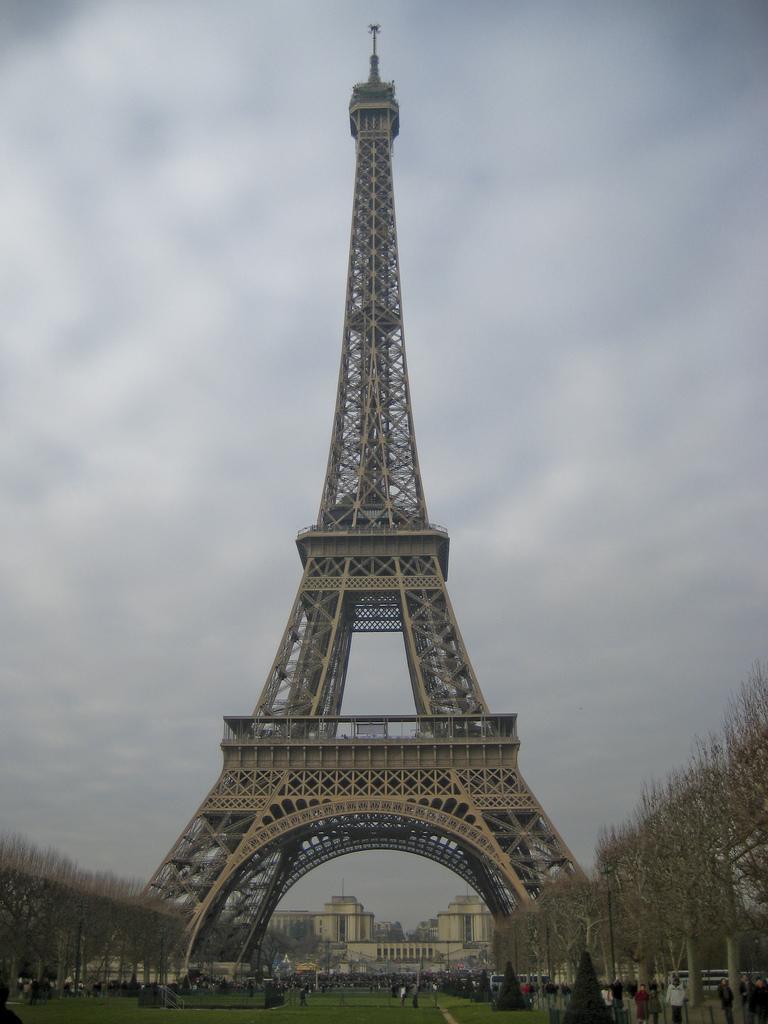Could you give a brief overview of what you see in this image? At the bottom we can see grass, trees and few persons are standing on the ground. On the left and right side we can see trees and poles. In the background we can see the Eiffel tower, buildings, trees and clouds in the sky. 